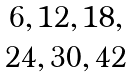Convert formula to latex. <formula><loc_0><loc_0><loc_500><loc_500>\begin{matrix} 6 , 1 2 , 1 8 , \\ 2 4 , 3 0 , 4 2 \end{matrix}</formula> 